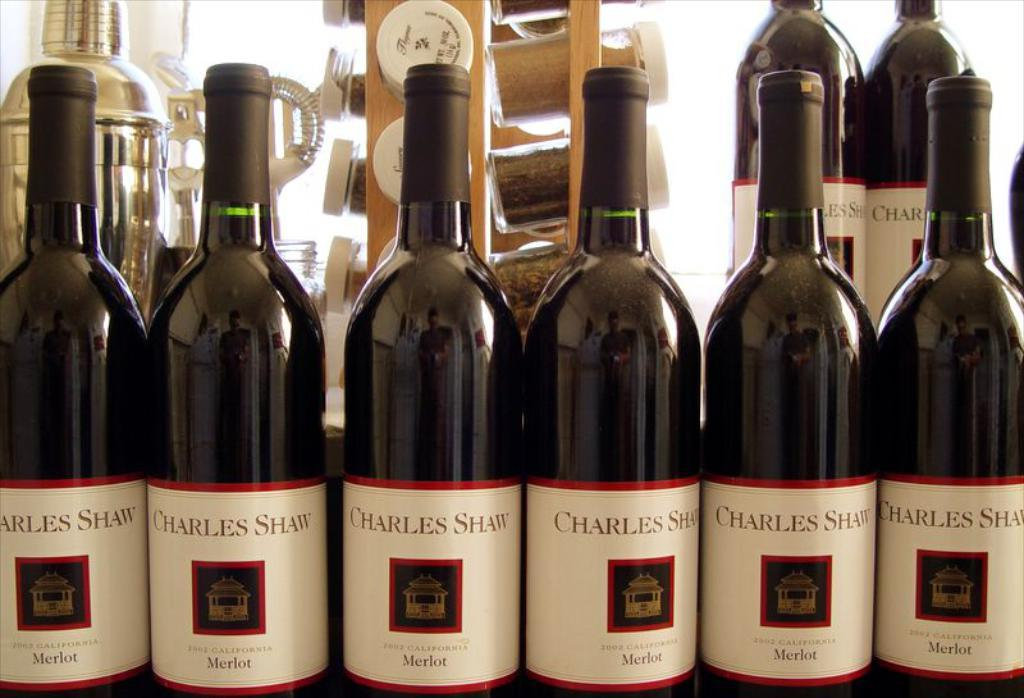<image>
Describe the image concisely. the word charles that is on a bottle 